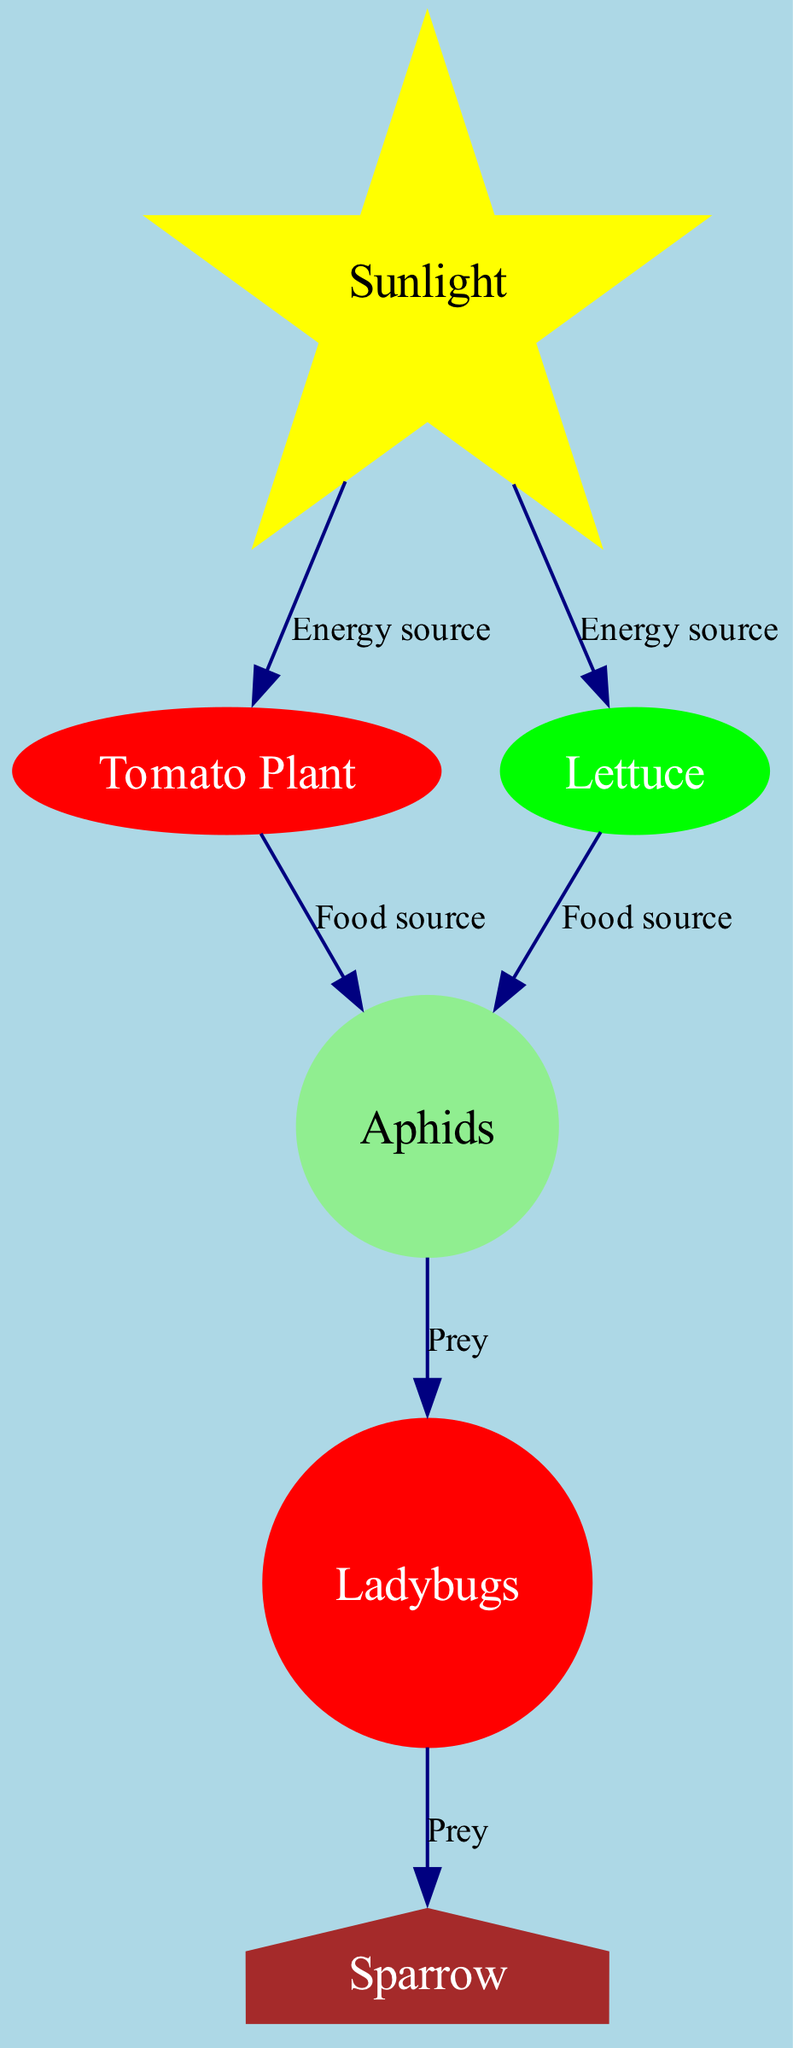What is the primary energy source for the tomato plant? The diagram shows an edge connecting "sunlight" to "tomato," labeled as "Energy source." This indicates that sunlight is essential for the growth of the tomato plant.
Answer: Sunlight How many food sources are there for aphids? The diagram has two edges directed towards "aphid," one from "tomato" and another from "lettuce," both labeled as "Food source." This highlights that aphids can feed on both plants.
Answer: 2 Which insect preys on the aphids? The diagram shows an edge from "aphid" to "ladybug," labeled as "Prey." This relationship demonstrates that ladybugs feed on aphids.
Answer: Ladybug What type of animal is the sparrow classified as in this food chain? The diagram has an edge from "ladybug" to "sparrow," labeled as "Prey." This implies that a sparrow is a consumer that preys on ladybugs. Since ladybugs feed on aphids, the sparrow indirectly benefits from this food chain.
Answer: Consumer How many nodes are present in the food chain diagram? The diagram lists six nodes: sunlight, tomato plant, lettuce, aphids, ladybugs, and sparrow. Counting all these nodes gives the total number of entities represented in the food chain.
Answer: 6 What do aphids primarily feed on? The diagram indicates two edges going into "aphid," one from "tomato" and another from "lettuce," both labeled as "Food source." This signifies that aphids primarily feed on both tomato plants and lettuce.
Answer: Tomato and lettuce Which node is the predator of the ladybug? The diagram shows an edge from "ladybug" to "sparrow," labeled as "Prey." This illustrates that the sparrow is the predator of the ladybug in this food chain.
Answer: Sparrow What is the function of sunlight in this ecosystem? The edges leading to the tomato and lettuce nodes from "sunlight" are both labeled as "Energy source." This indicates that sunlight is crucial for providing energy to the plants within the ecosystem.
Answer: Energy source 